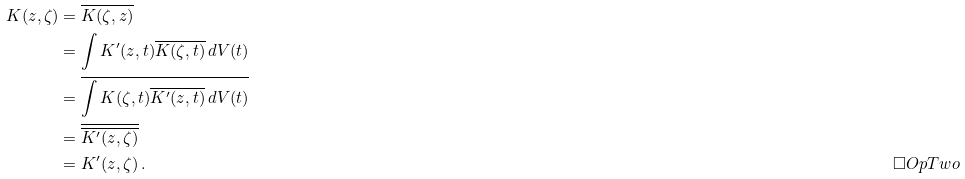Convert formula to latex. <formula><loc_0><loc_0><loc_500><loc_500>K ( z , \zeta ) & = \overline { K ( \zeta , z ) } \\ & = \int K ^ { \prime } ( z , t ) \overline { K ( \zeta , t ) } \, d V ( t ) \\ & = \overline { \int K ( \zeta , t ) \overline { K ^ { \prime } ( z , t ) } \, d V ( t ) } \\ & = \overline { \overline { K ^ { \prime } ( z , \zeta ) } } \\ & = K ^ { \prime } ( z , \zeta ) \, . \tag* { $ \Box O p T w o $ }</formula> 